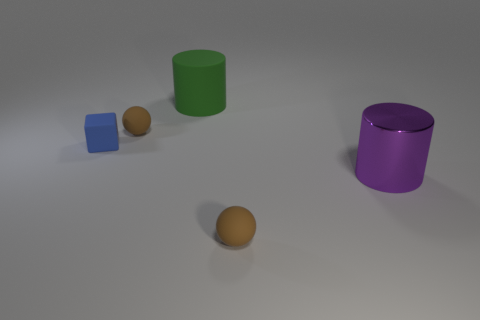Add 5 matte balls. How many objects exist? 10 Subtract all cubes. How many objects are left? 4 Subtract all blue cylinders. Subtract all green cylinders. How many objects are left? 4 Add 5 matte balls. How many matte balls are left? 7 Add 2 small blue matte things. How many small blue matte things exist? 3 Subtract 0 brown cylinders. How many objects are left? 5 